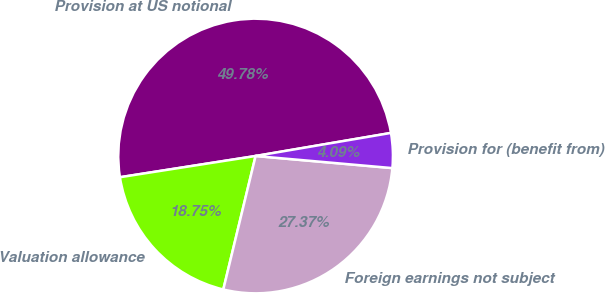Convert chart. <chart><loc_0><loc_0><loc_500><loc_500><pie_chart><fcel>Provision at US notional<fcel>Valuation allowance<fcel>Foreign earnings not subject<fcel>Provision for (benefit from)<nl><fcel>49.78%<fcel>18.75%<fcel>27.37%<fcel>4.09%<nl></chart> 